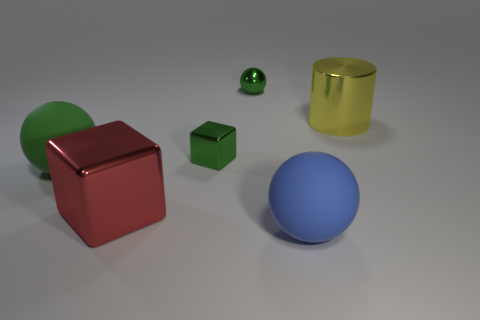What shape is the small object that is the same color as the shiny ball?
Your response must be concise. Cube. Is the number of red things that are in front of the large green rubber object less than the number of big blue matte spheres?
Provide a short and direct response. No. Is the shape of the big yellow shiny object the same as the big red object?
Offer a terse response. No. There is a green sphere that is made of the same material as the yellow thing; what is its size?
Offer a terse response. Small. Is the number of large blue balls less than the number of metal cubes?
Keep it short and to the point. Yes. How many big things are either brown spheres or rubber balls?
Give a very brief answer. 2. How many large objects are in front of the big green sphere and on the right side of the large metal cube?
Provide a succinct answer. 1. Is the number of big green things greater than the number of objects?
Your response must be concise. No. How many other things are there of the same shape as the big blue object?
Your response must be concise. 2. Is the tiny metal block the same color as the tiny ball?
Provide a succinct answer. Yes. 